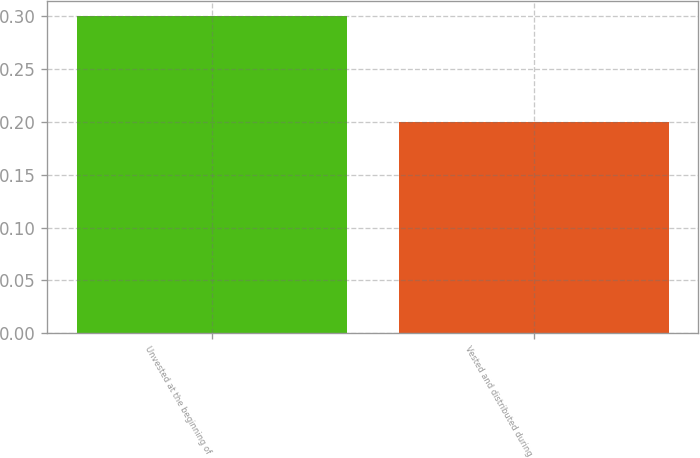<chart> <loc_0><loc_0><loc_500><loc_500><bar_chart><fcel>Unvested at the beginning of<fcel>Vested and distributed during<nl><fcel>0.3<fcel>0.2<nl></chart> 